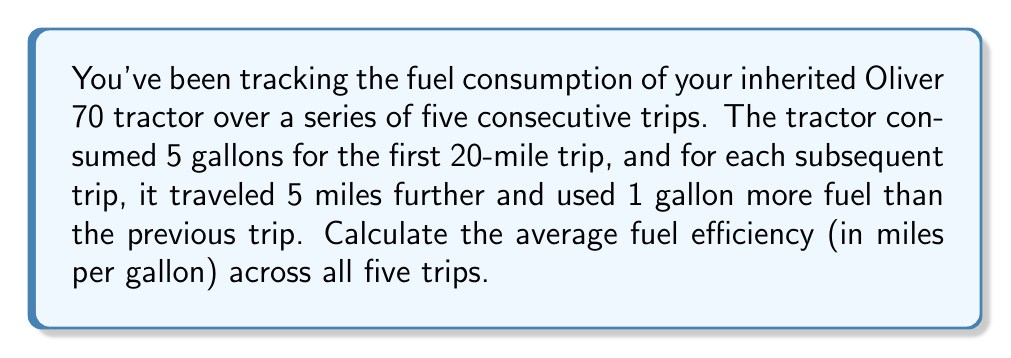Could you help me with this problem? Let's approach this step-by-step:

1) First, let's list out the data for each trip:
   Trip 1: 20 miles, 5 gallons
   Trip 2: 25 miles, 6 gallons
   Trip 3: 30 miles, 7 gallons
   Trip 4: 35 miles, 8 gallons
   Trip 5: 40 miles, 9 gallons

2) To calculate the average fuel efficiency, we need:
   $$\text{Average Efficiency} = \frac{\text{Total Distance}}{\text{Total Fuel Consumed}}$$

3) Let's calculate the total distance:
   $$\text{Total Distance} = 20 + 25 + 30 + 35 + 40 = 150 \text{ miles}$$

4) Now, let's calculate the total fuel consumed:
   $$\text{Total Fuel} = 5 + 6 + 7 + 8 + 9 = 35 \text{ gallons}$$

5) Now we can calculate the average fuel efficiency:
   $$\text{Average Efficiency} = \frac{150 \text{ miles}}{35 \text{ gallons}} = \frac{30}{7} \approx 4.29 \text{ miles per gallon}$$

6) Rounding to two decimal places:
   $$\text{Average Efficiency} \approx 4.29 \text{ miles per gallon}$$
Answer: 4.29 miles per gallon 